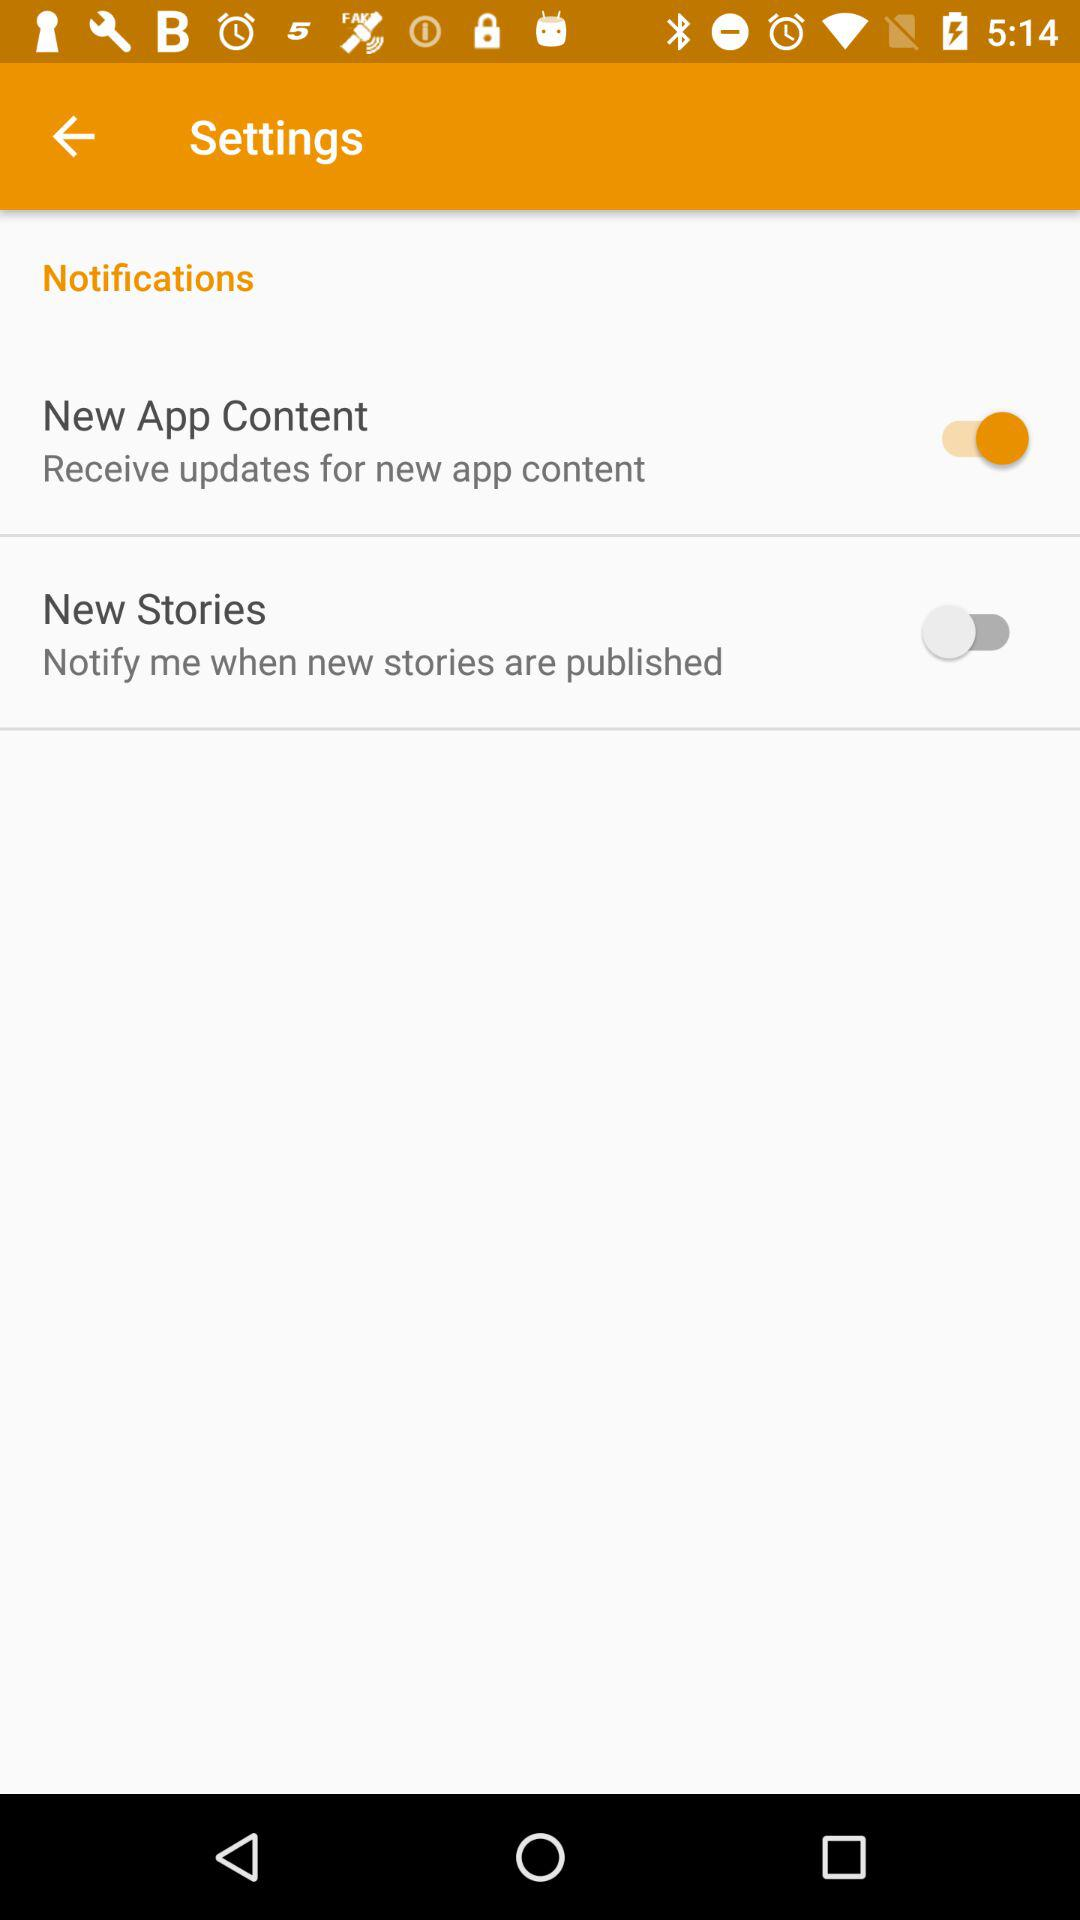What is the status of the "New App Content"? The status is on. 